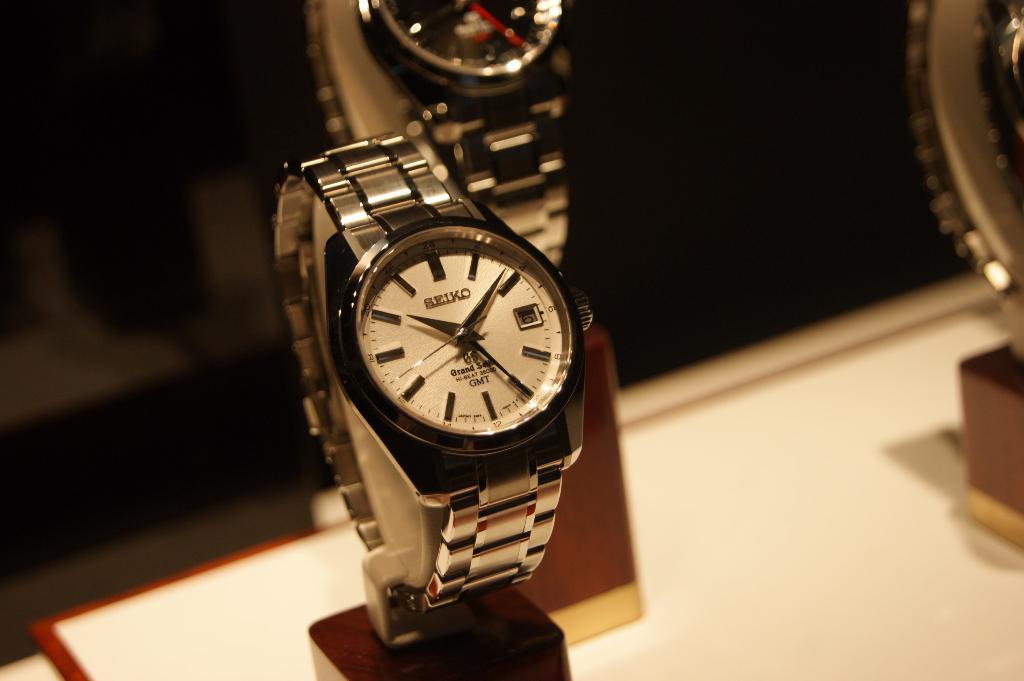Who makes this watch?
Ensure brevity in your answer.  Seiko. What time is shown?
Provide a succinct answer. 10:09. 